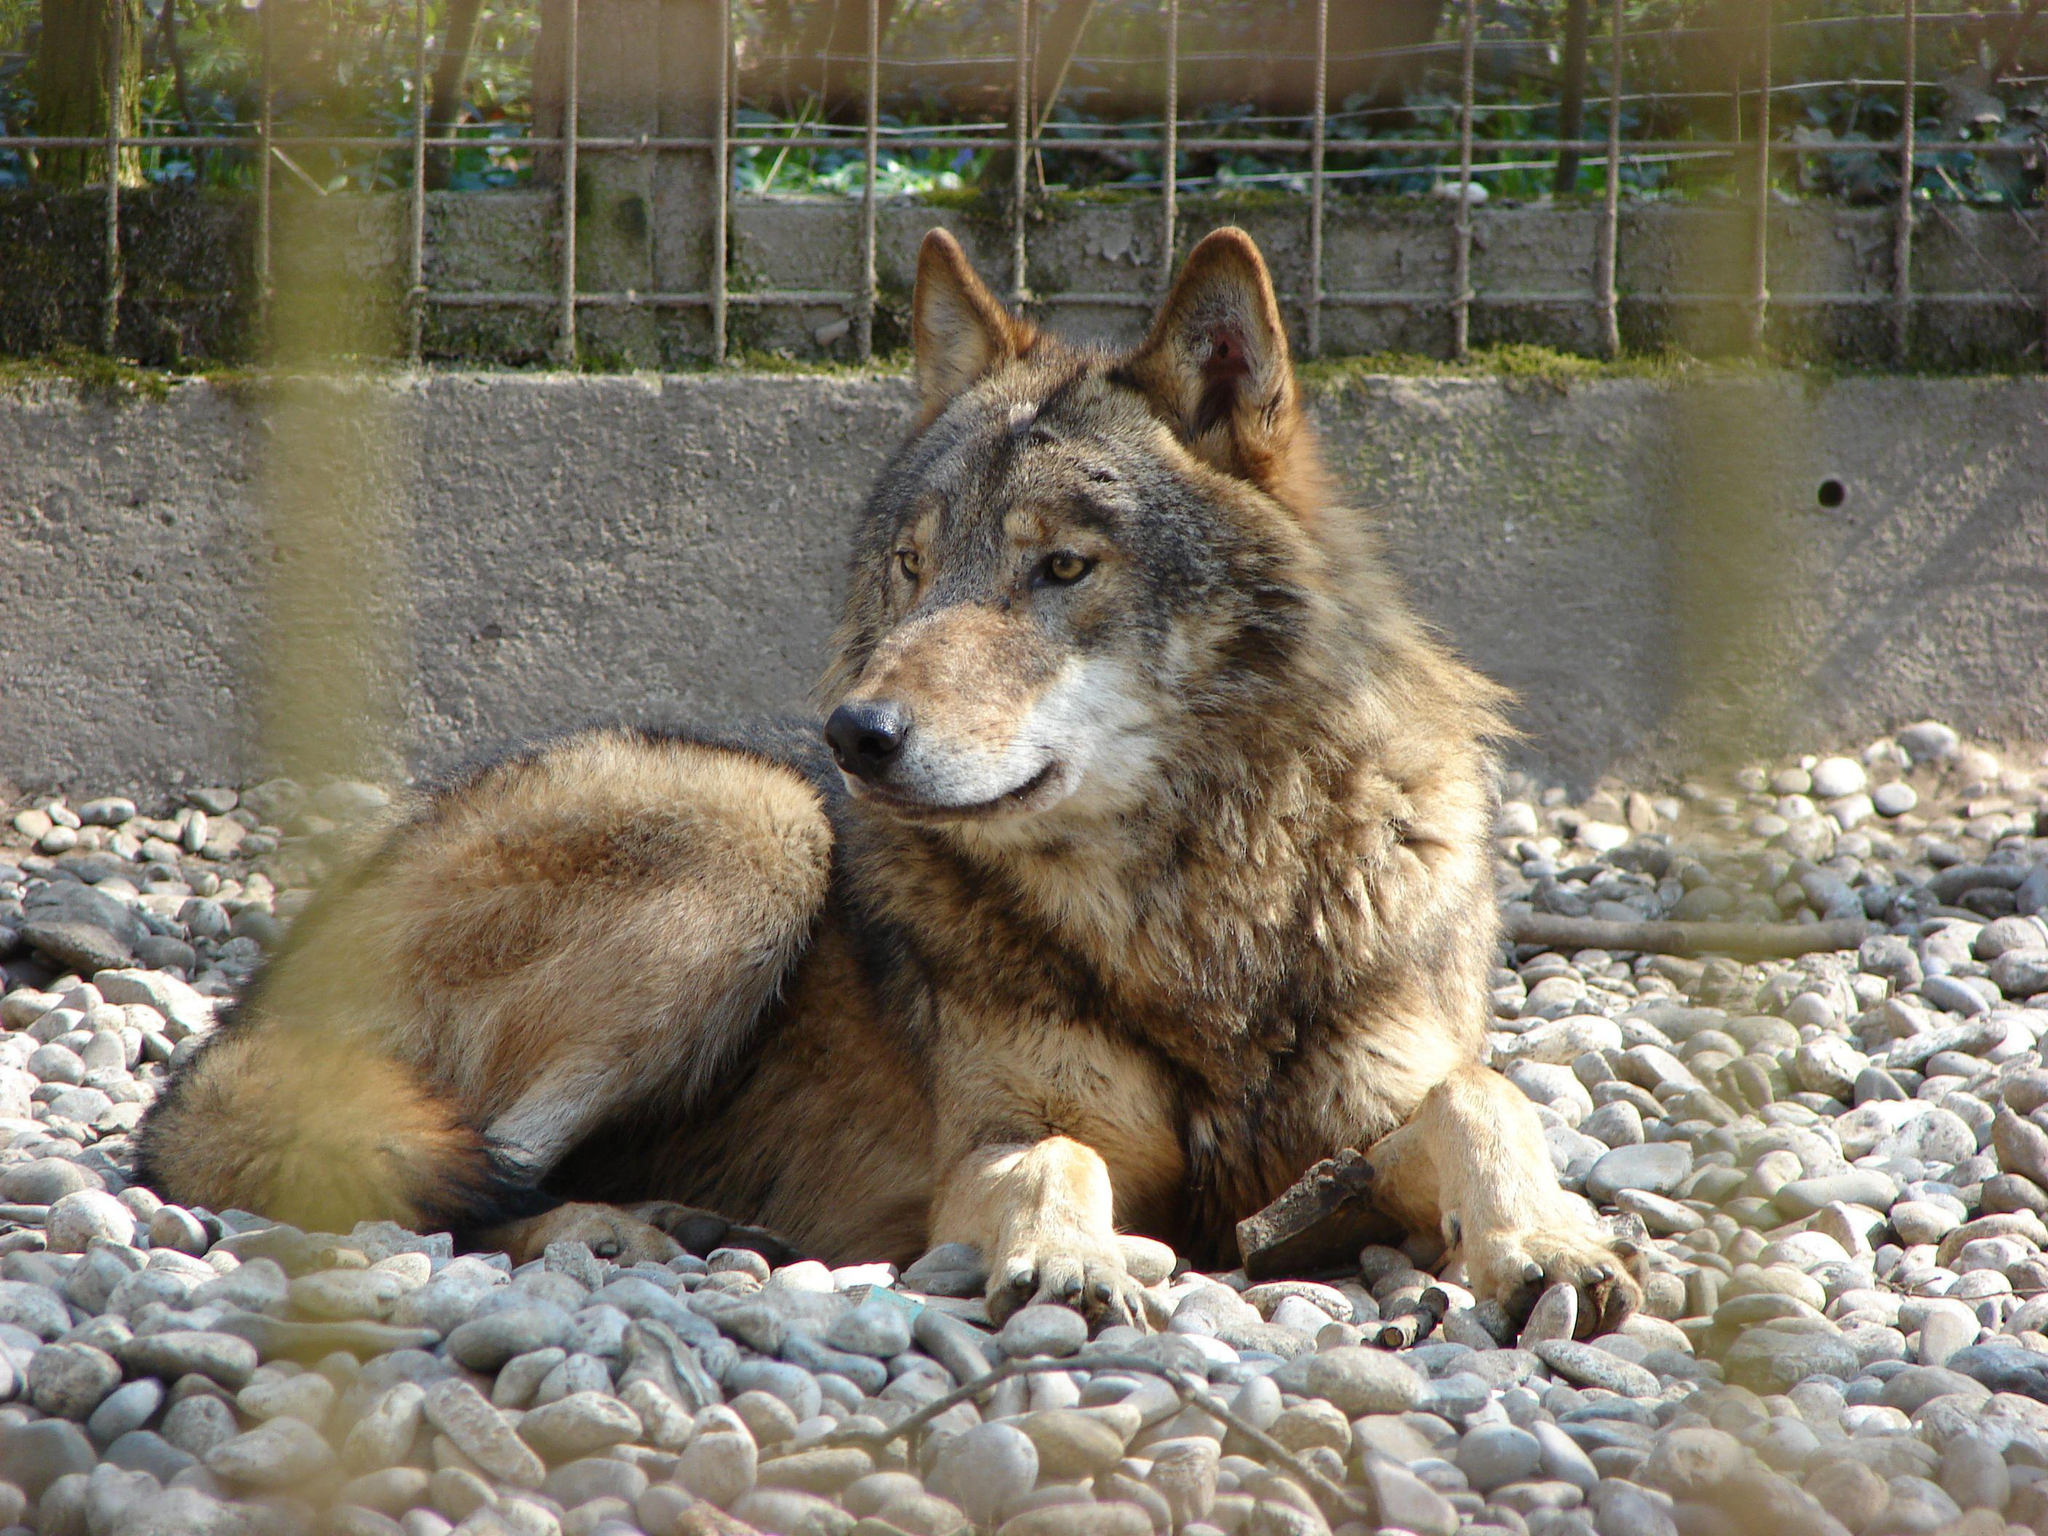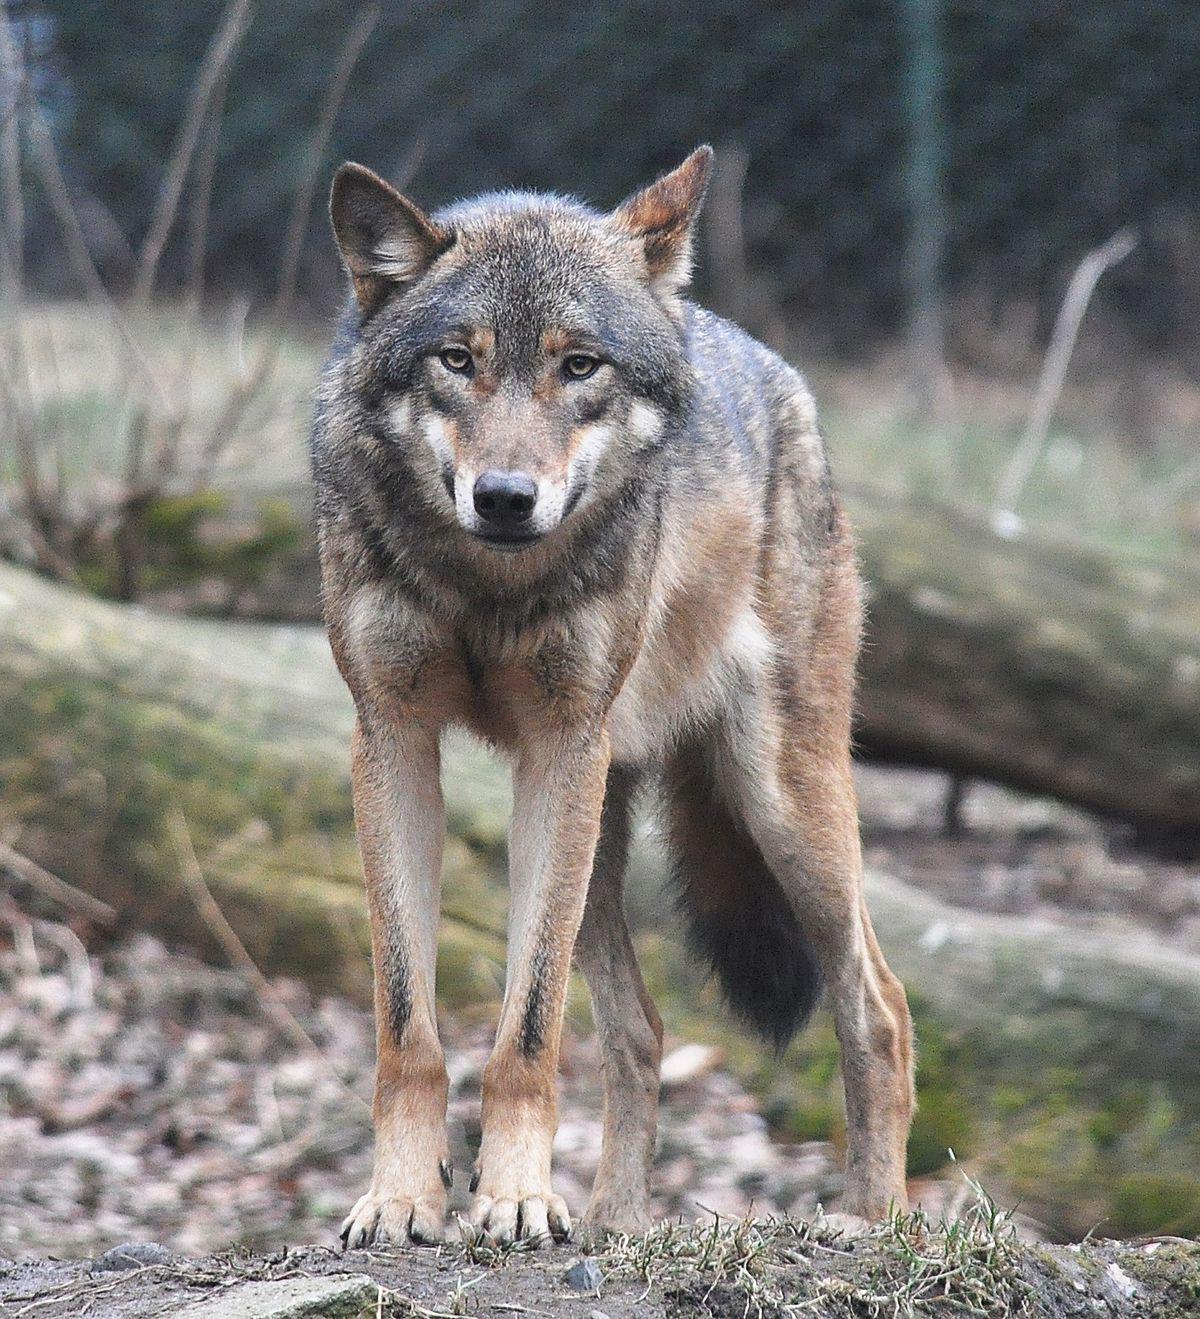The first image is the image on the left, the second image is the image on the right. Evaluate the accuracy of this statement regarding the images: "An image shows one wolf resting on the snow with front paws extended forward.". Is it true? Answer yes or no. No. The first image is the image on the left, the second image is the image on the right. For the images displayed, is the sentence "An image shows a tawny wolf lying on the ground with front paws forward and head up." factually correct? Answer yes or no. Yes. The first image is the image on the left, the second image is the image on the right. Given the left and right images, does the statement "In 1 of the images, 1 wolf is seated in snow." hold true? Answer yes or no. No. The first image is the image on the left, the second image is the image on the right. Given the left and right images, does the statement "The animal in the image on the left is on snow." hold true? Answer yes or no. No. 